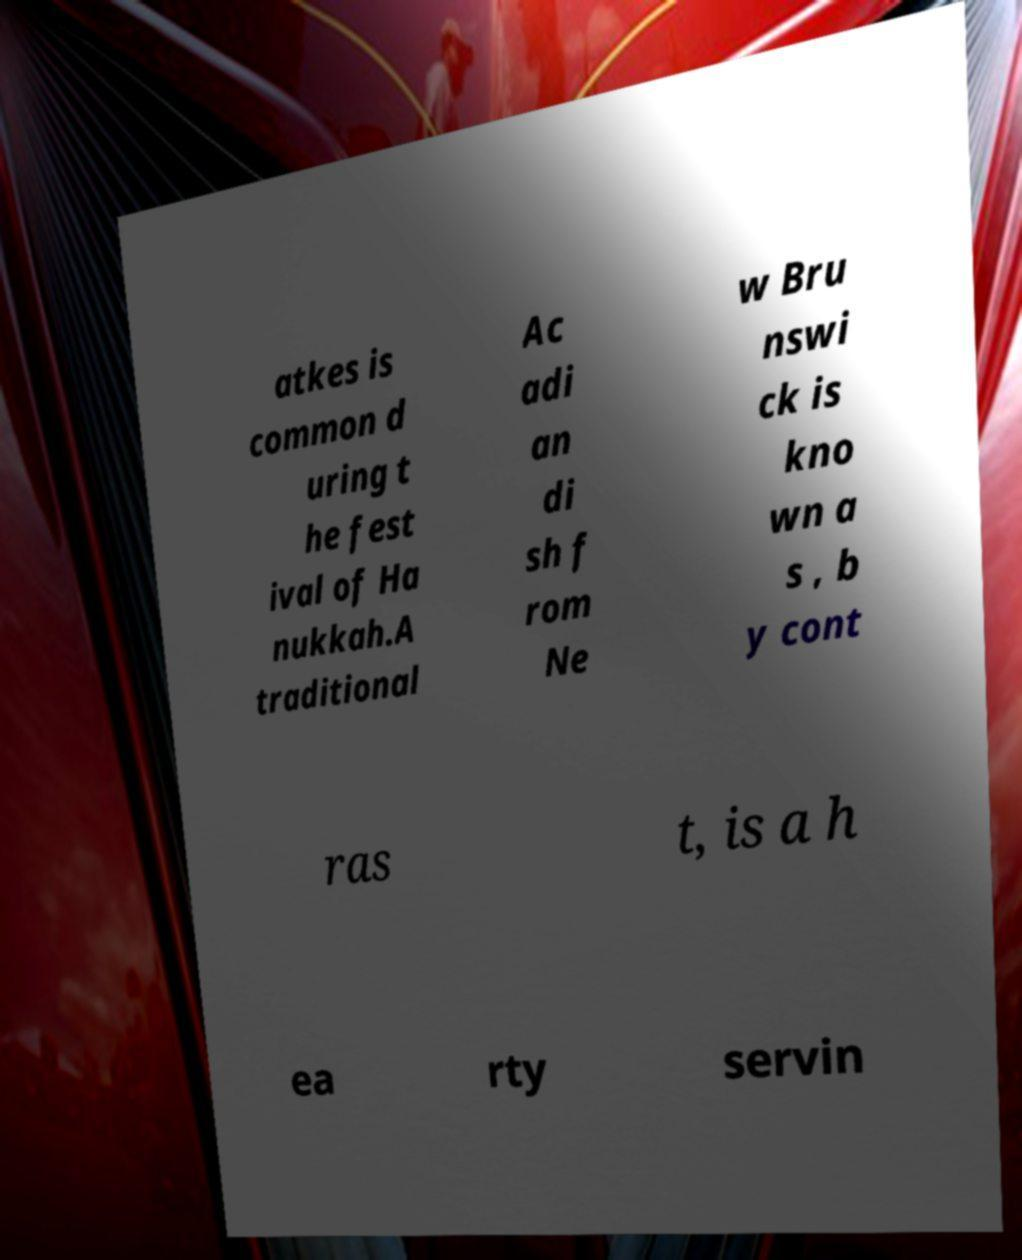Could you extract and type out the text from this image? atkes is common d uring t he fest ival of Ha nukkah.A traditional Ac adi an di sh f rom Ne w Bru nswi ck is kno wn a s , b y cont ras t, is a h ea rty servin 